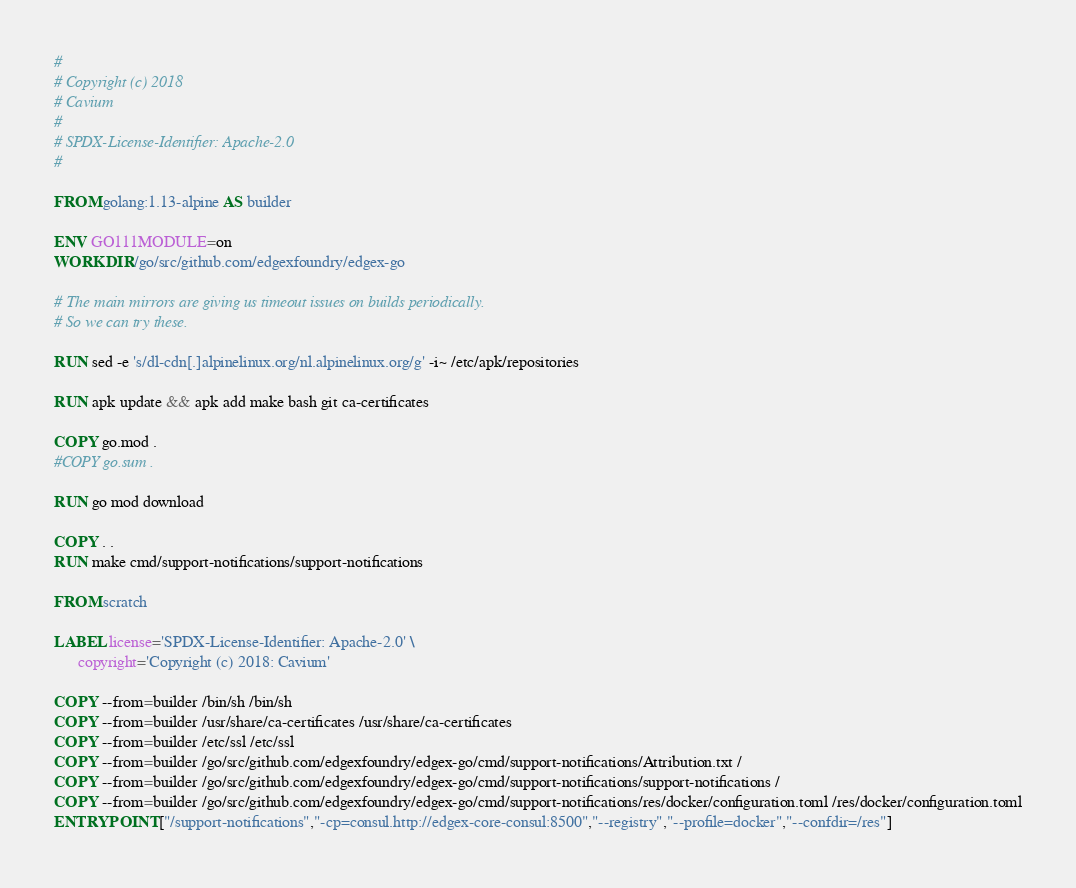<code> <loc_0><loc_0><loc_500><loc_500><_Dockerfile_>#
# Copyright (c) 2018
# Cavium
#
# SPDX-License-Identifier: Apache-2.0
#

FROM golang:1.13-alpine AS builder

ENV GO111MODULE=on
WORKDIR /go/src/github.com/edgexfoundry/edgex-go

# The main mirrors are giving us timeout issues on builds periodically.
# So we can try these.

RUN sed -e 's/dl-cdn[.]alpinelinux.org/nl.alpinelinux.org/g' -i~ /etc/apk/repositories

RUN apk update && apk add make bash git ca-certificates

COPY go.mod .
#COPY go.sum .

RUN go mod download

COPY . .
RUN make cmd/support-notifications/support-notifications

FROM scratch

LABEL license='SPDX-License-Identifier: Apache-2.0' \
      copyright='Copyright (c) 2018: Cavium'

COPY --from=builder /bin/sh /bin/sh
COPY --from=builder /usr/share/ca-certificates /usr/share/ca-certificates
COPY --from=builder /etc/ssl /etc/ssl
COPY --from=builder /go/src/github.com/edgexfoundry/edgex-go/cmd/support-notifications/Attribution.txt /
COPY --from=builder /go/src/github.com/edgexfoundry/edgex-go/cmd/support-notifications/support-notifications /
COPY --from=builder /go/src/github.com/edgexfoundry/edgex-go/cmd/support-notifications/res/docker/configuration.toml /res/docker/configuration.toml
ENTRYPOINT ["/support-notifications","-cp=consul.http://edgex-core-consul:8500","--registry","--profile=docker","--confdir=/res"]
</code> 